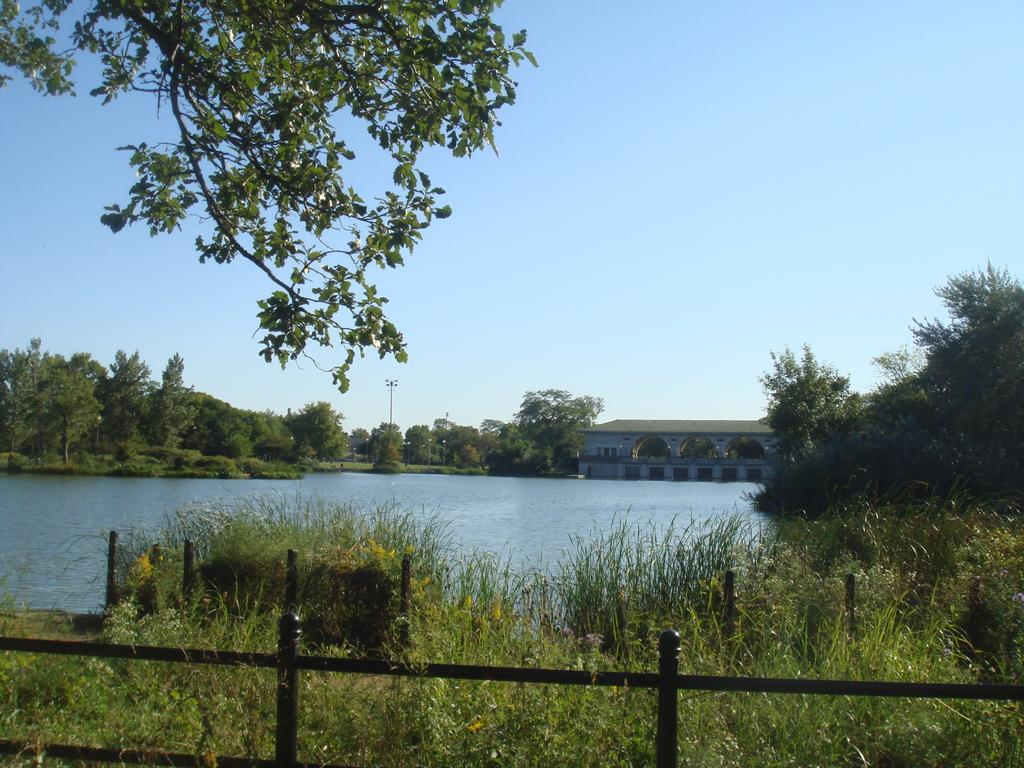What type of vegetation is present in the image? There is grass in the image. What type of structure can be seen in the image? There is fencing in the image. What natural element is visible in the image? There is water in the image. What can be seen in the background of the image? There are trees and a house in the background of the image. What is visible at the top of the image? The sky is clear and visible at the top of the image. Can you see a tiger playing with a boy near the water in the image? No, there is no tiger or boy present in the image. Is there a fire burning near the house in the background of the image? No, there is no fire visible in the image. 